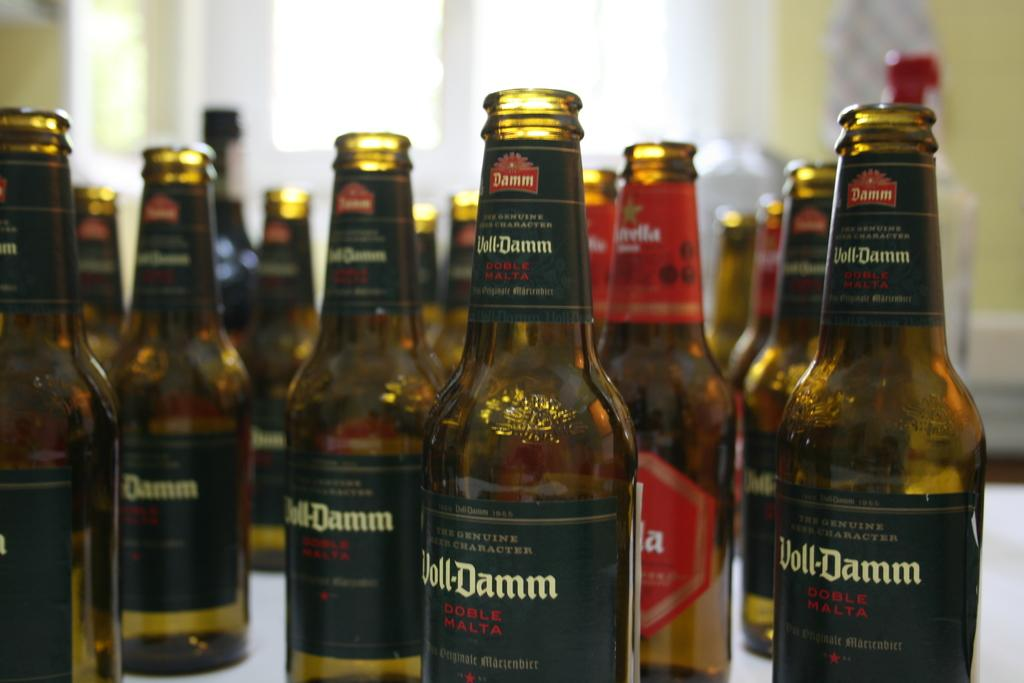<image>
Give a short and clear explanation of the subsequent image. Voll-Damm beer bottles that are stacked on a table. 